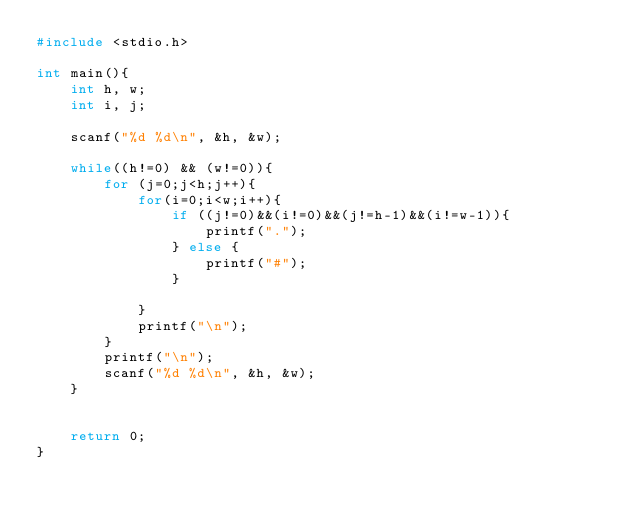<code> <loc_0><loc_0><loc_500><loc_500><_C_>#include <stdio.h>

int main(){
    int h, w;
    int i, j;
    
    scanf("%d %d\n", &h, &w);
    
    while((h!=0) && (w!=0)){
        for (j=0;j<h;j++){
            for(i=0;i<w;i++){
                if ((j!=0)&&(i!=0)&&(j!=h-1)&&(i!=w-1)){
                    printf(".");                   
                } else {
                    printf("#");
                }

            }
            printf("\n");
        }
        printf("\n");
        scanf("%d %d\n", &h, &w);        
    }
    

    return 0;
}
</code> 